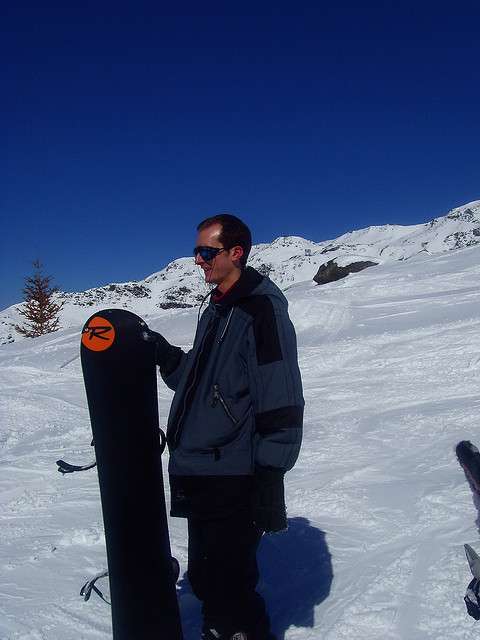<image>What is this man thinking? It is unknown what this man is thinking. What is this man thinking? I don't know what this man is thinking. It could be any of the given options. 